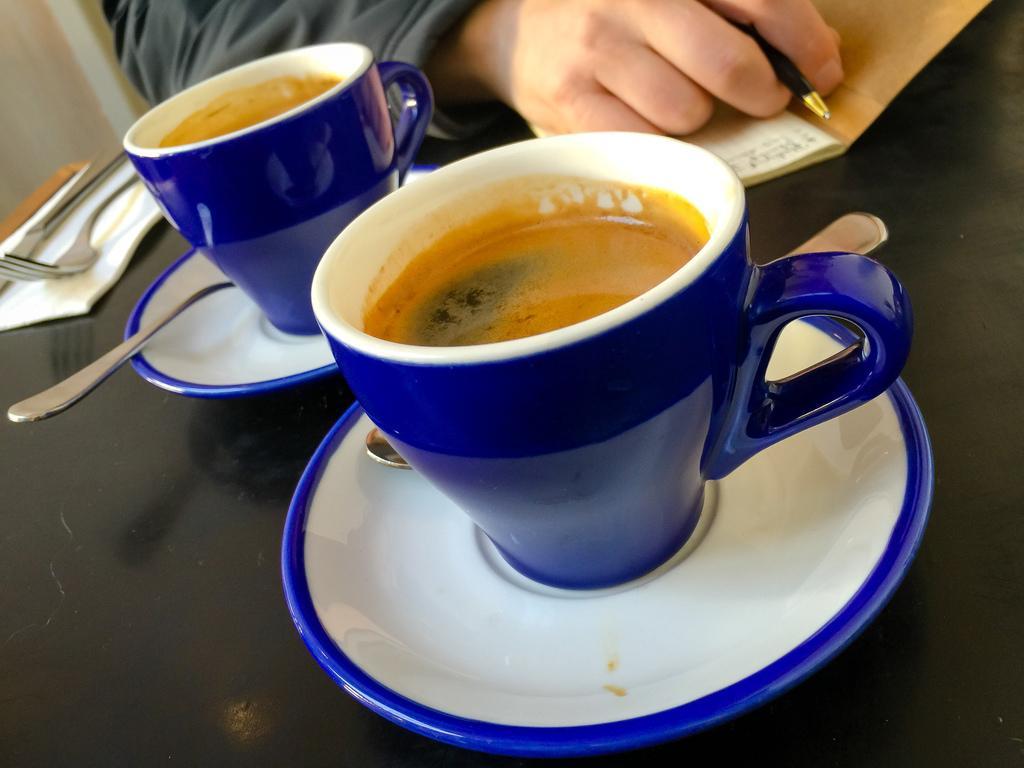Can you describe this image briefly? In this image I can see coffee cups, saucers, spoons, fork, knife and tissue paper is on the black platform. At the top of the image we can see a person hand and book. A person is holding a pen.   